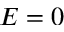Convert formula to latex. <formula><loc_0><loc_0><loc_500><loc_500>E = 0</formula> 